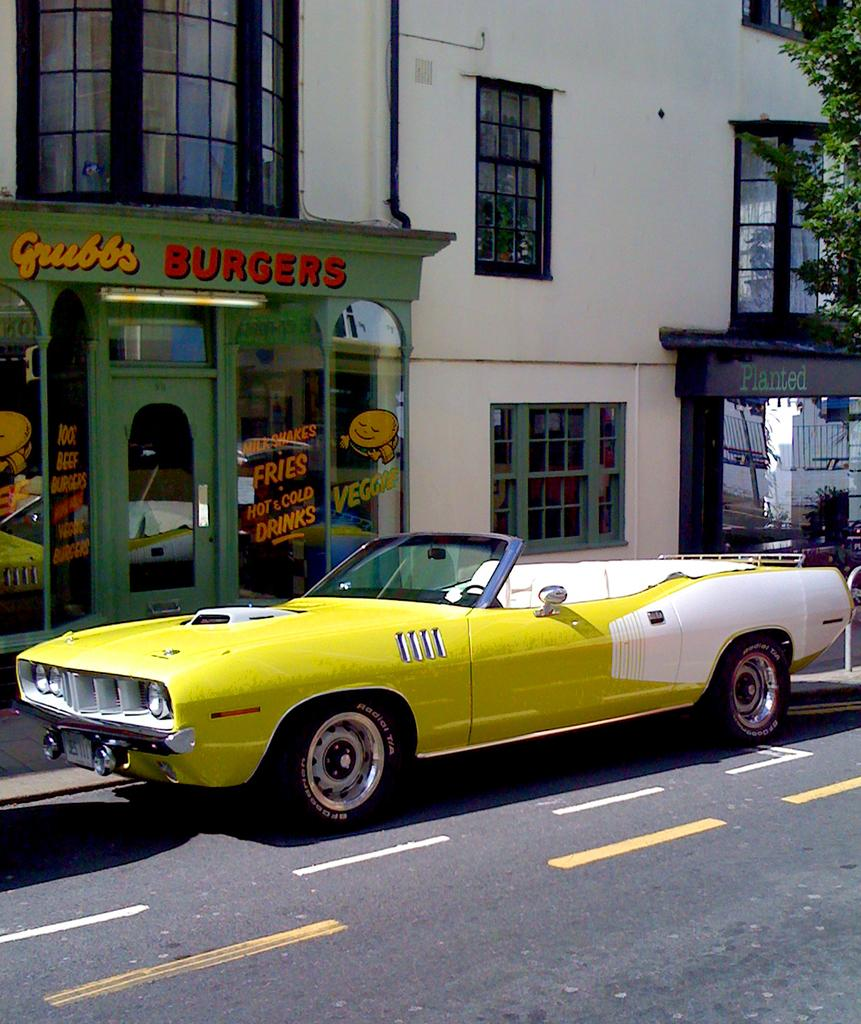What is the main subject of the image? There is a car in the image. Where is the car located in relation to the building? The car is in front of a building. What can be seen in the top right corner of the image? There is a branch in the top right corner of the image. What type of tooth is visible in the image? There is no tooth present in the image. What sound does the car make in the image? The image is still, so it does not depict any sounds, including the car's horn. 